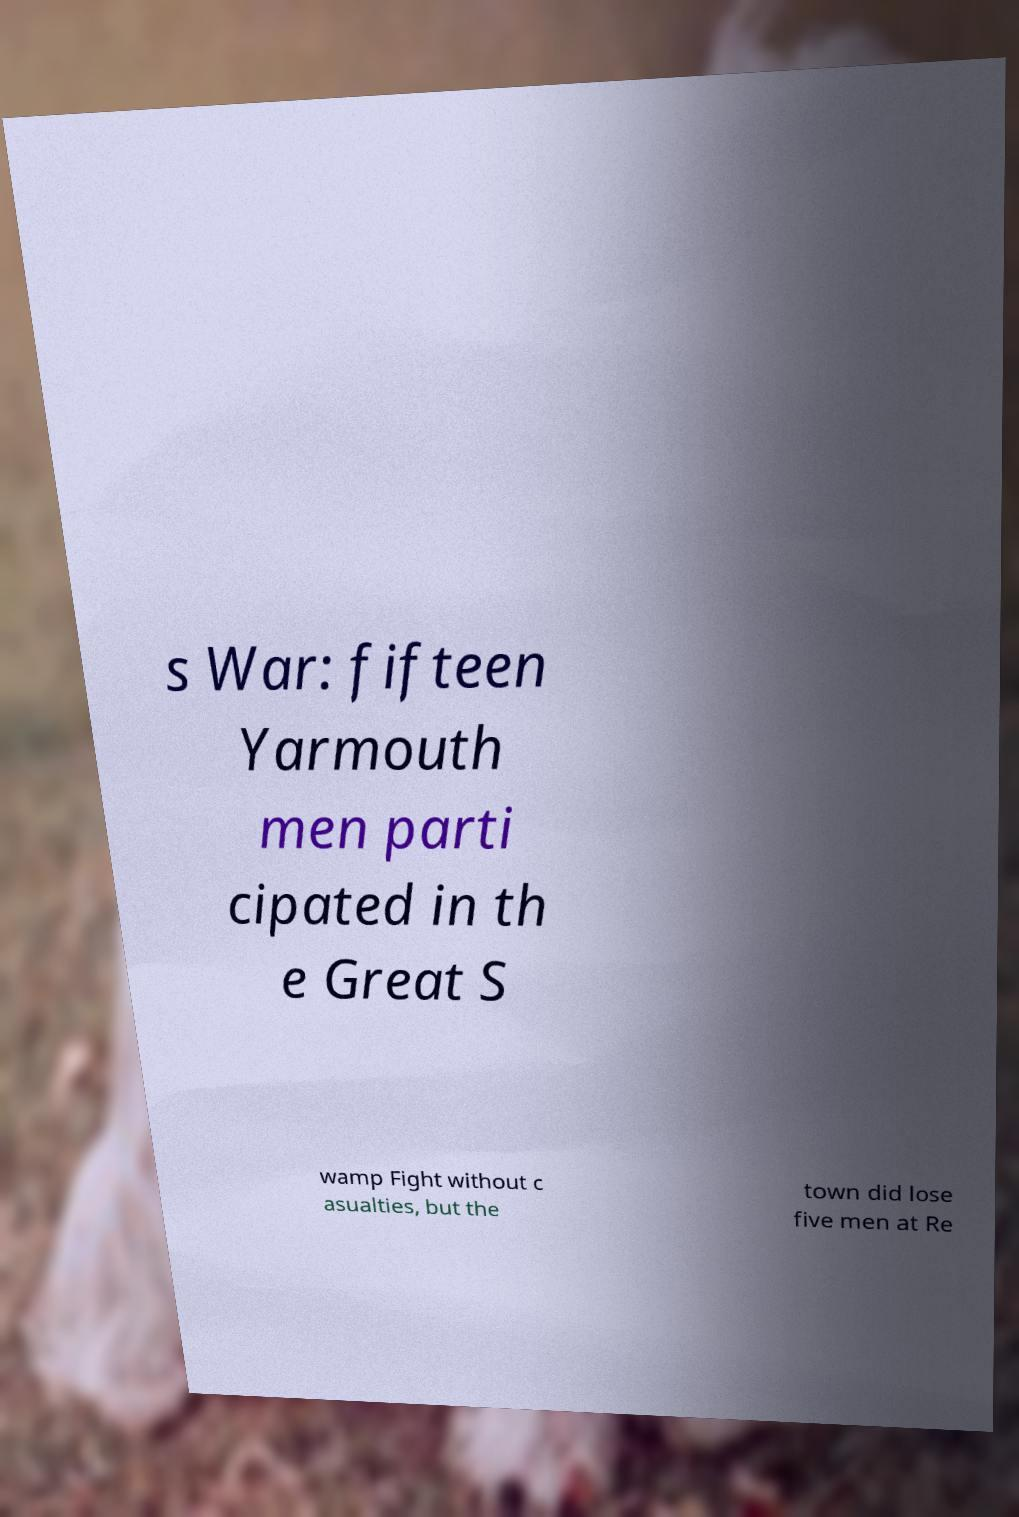Could you extract and type out the text from this image? s War: fifteen Yarmouth men parti cipated in th e Great S wamp Fight without c asualties, but the town did lose five men at Re 